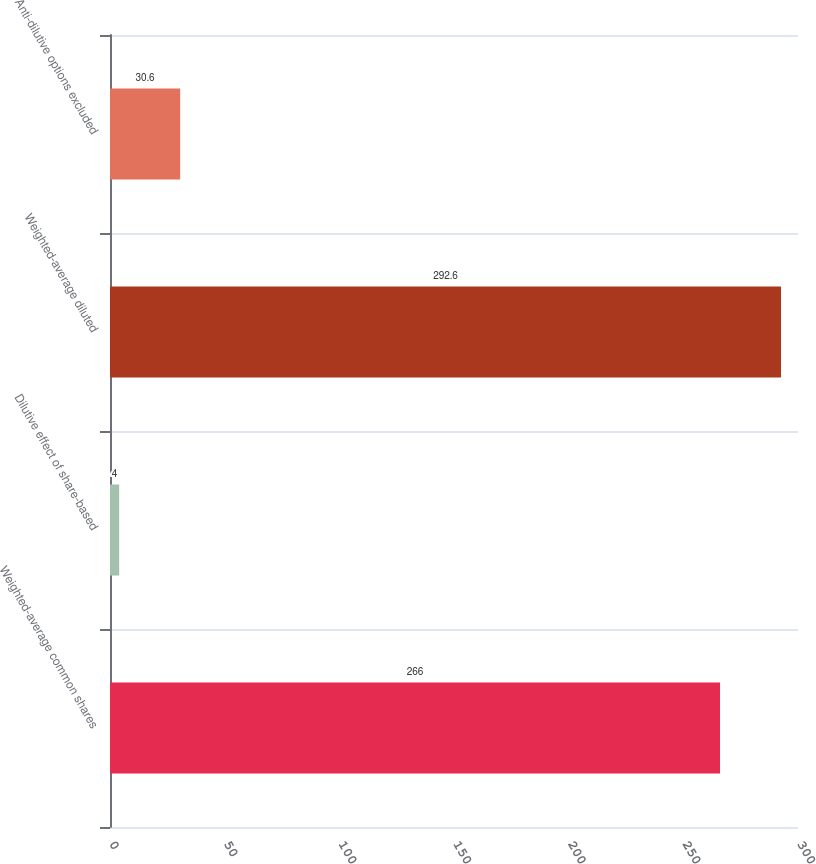Convert chart. <chart><loc_0><loc_0><loc_500><loc_500><bar_chart><fcel>Weighted-average common shares<fcel>Dilutive effect of share-based<fcel>Weighted-average diluted<fcel>Anti-dilutive options excluded<nl><fcel>266<fcel>4<fcel>292.6<fcel>30.6<nl></chart> 